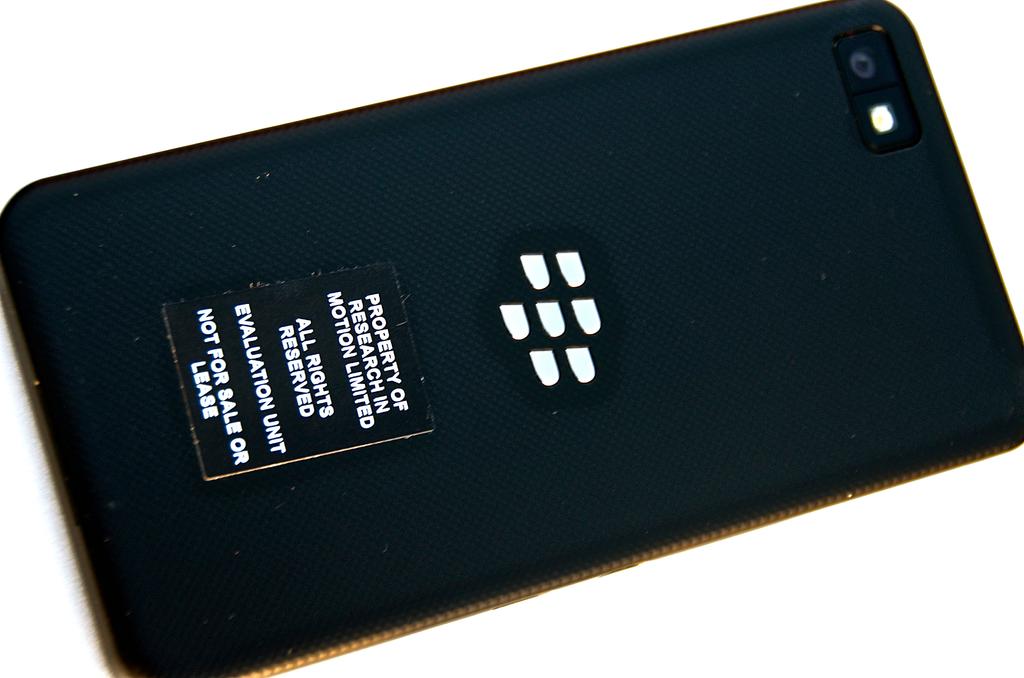To whom is this device property of?
Your response must be concise. Research in motion limited. Is this for sale or for lease?
Ensure brevity in your answer.  No. 